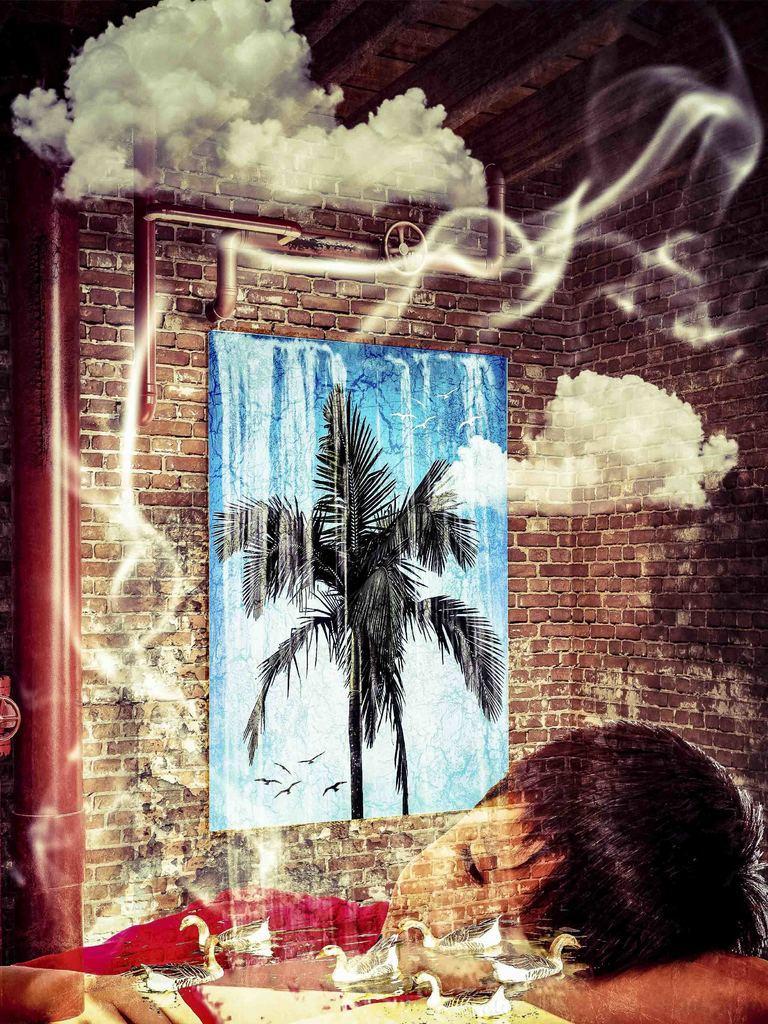In one or two sentences, can you explain what this image depicts? This is an edited image. At the bottom of the image I can see a baby and few birds. In the background there is a wall to which a poster is attached. On this poster I can see a painting of a tree. At the top of the image I can see the clouds. 